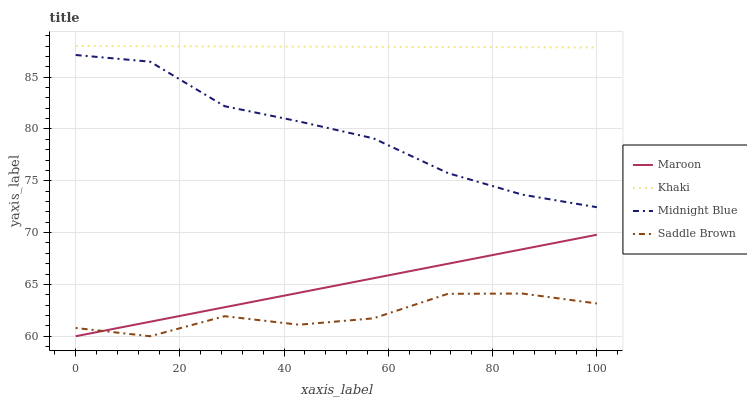Does Saddle Brown have the minimum area under the curve?
Answer yes or no. Yes. Does Khaki have the maximum area under the curve?
Answer yes or no. Yes. Does Midnight Blue have the minimum area under the curve?
Answer yes or no. No. Does Midnight Blue have the maximum area under the curve?
Answer yes or no. No. Is Khaki the smoothest?
Answer yes or no. Yes. Is Saddle Brown the roughest?
Answer yes or no. Yes. Is Midnight Blue the smoothest?
Answer yes or no. No. Is Midnight Blue the roughest?
Answer yes or no. No. Does Midnight Blue have the lowest value?
Answer yes or no. No. Does Midnight Blue have the highest value?
Answer yes or no. No. Is Saddle Brown less than Khaki?
Answer yes or no. Yes. Is Midnight Blue greater than Saddle Brown?
Answer yes or no. Yes. Does Saddle Brown intersect Khaki?
Answer yes or no. No. 